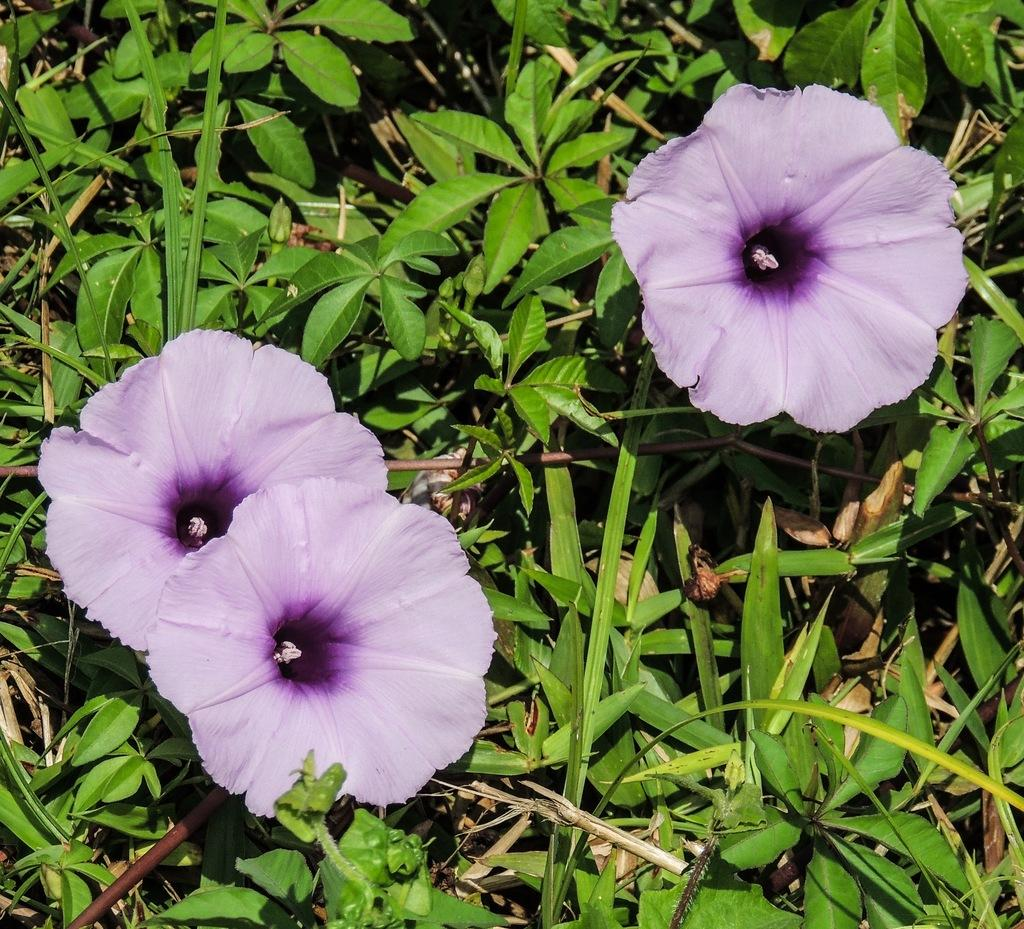How many flowers are present in the image? There are 3 flowers in the image. What color are the flowers? The flowers are in brinjal color. What other types of vegetation can be seen in the image? There are plants and grass in the image. What type of scent can be detected from the flowers in the image? The image does not provide any information about the scent of the flowers, so it cannot be determined from the picture. 